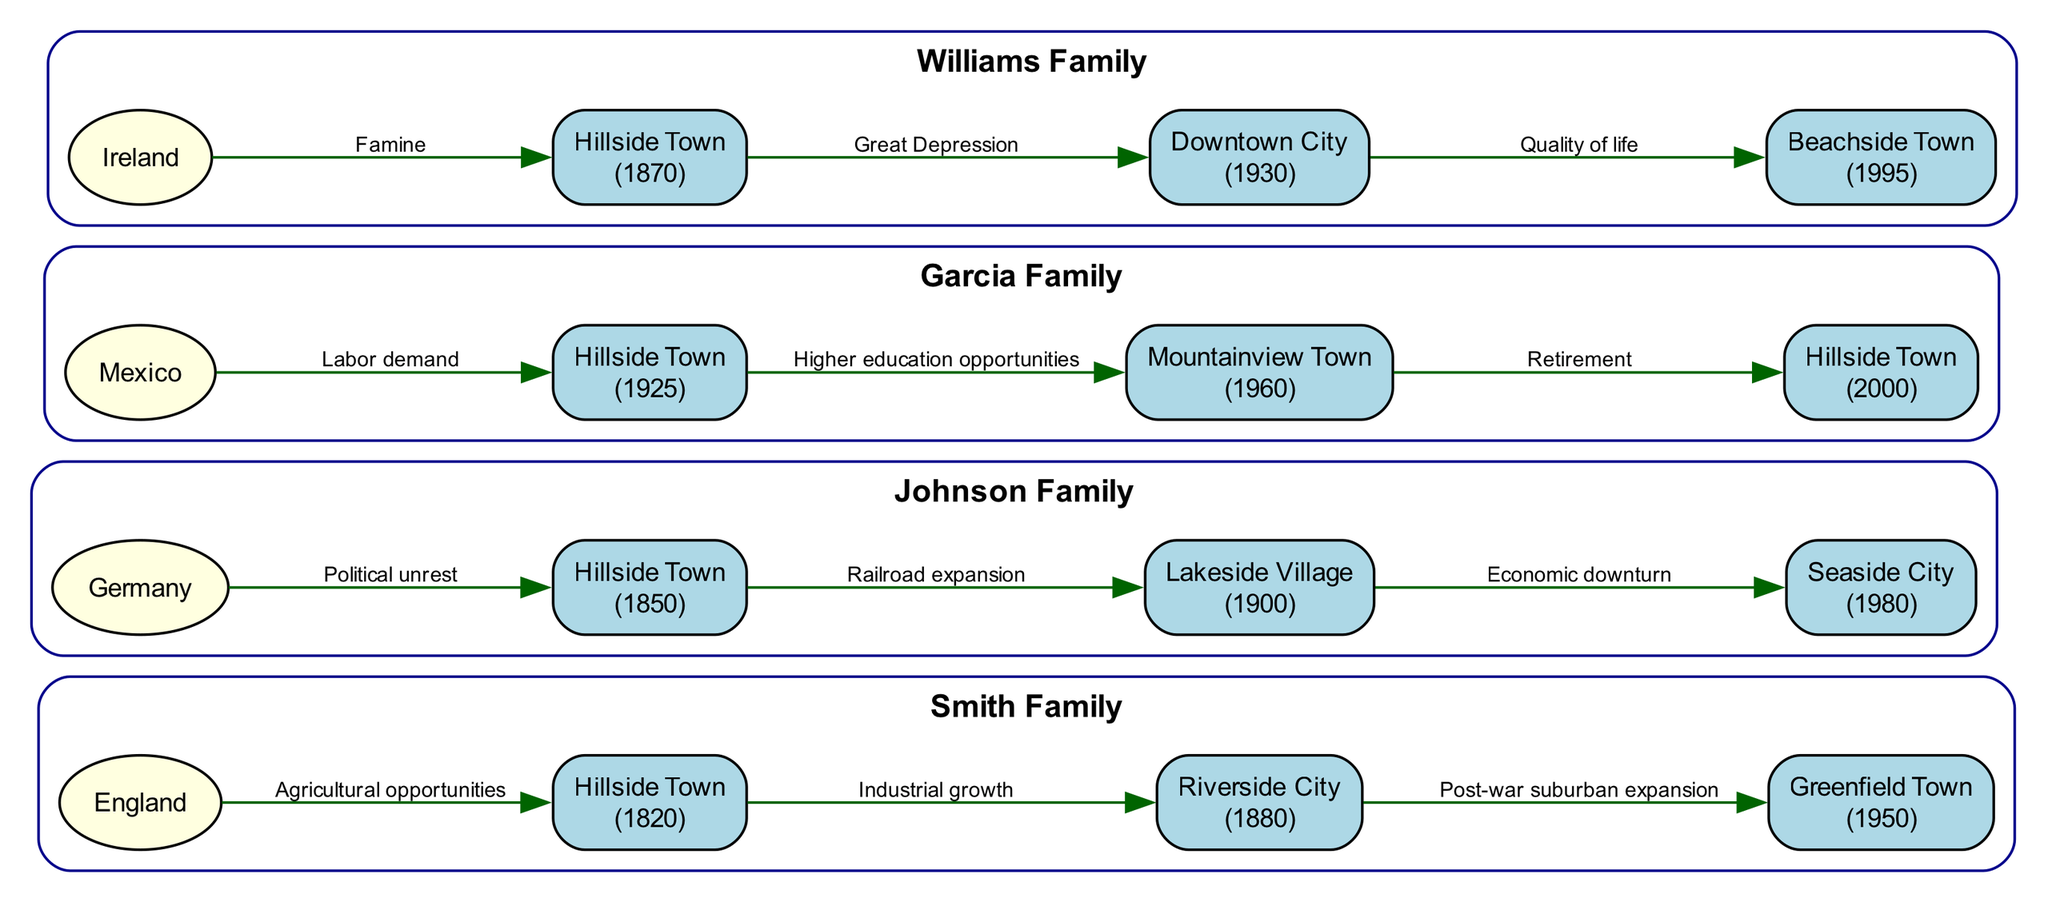What is the first migration year for the Smith Family? The Smith Family's first migration point is listed as the year 1820. This is obtained by looking at the first entry in the migration_points for the Smith Family.
Answer: 1820 How many migration points are there for the Johnson Family? The Johnson Family has three migration points as shown in their migration_points list. This is counted directly from the data given for the Johnson Family, which includes three entries.
Answer: 3 What was the reason for the Williams Family's move to Beachside Town? The reason provided in the migration point for the Williams Family's move to Beachside Town in 1995 is "Quality of life." This can be found above the edge leading to the Beachside Town node.
Answer: Quality of life Which family migrated from Germany, and in what year? The Johnson Family is the one that migrated from Germany, and they did so in the year 1850. This is verified by inspecting the migration_points for the Johnson Family.
Answer: Johnson Family, 1850 What is the destination for the Garcia Family in 1960? The Garcia Family's migration point in 1960 shows that their destination was Mountainview Town. This can be seen directly from the migration point for the year 1960 for the Garcia Family.
Answer: Mountainview Town How many families migrated to Hillside Town in the 19th century? Two families migrated to Hillside Town in the 19th century: the Smith Family in 1820 and the Johnson Family in 1850. The years and families can be counted by examining the migration points across all families in the diagram.
Answer: 2 What event prompted the Williams Family to leave Hillside Town in 1930? The Williams Family left Hillside Town in 1930 due to the "Great Depression". This reason is stated directly on the edge connecting their origin node to their destination node.
Answer: Great Depression What was a common reason for migration among all the families in the 20th century? A common reason for migration among all families in the 20th century is the pursuit of better opportunities, such as education in the Garcia Family's case and quality of life for the Williams Family. This conclusion requires reviewing various migration points for each family from the 1900s onward.
Answer: Better opportunities Which family's migration includes returning to Hillside Town in 2000? The Garcia Family is noted for returning to Hillside Town in 2000, as indicated by their last migration point. This is determined by reviewing the migration_points listed for the Garcia Family.
Answer: Garcia Family 